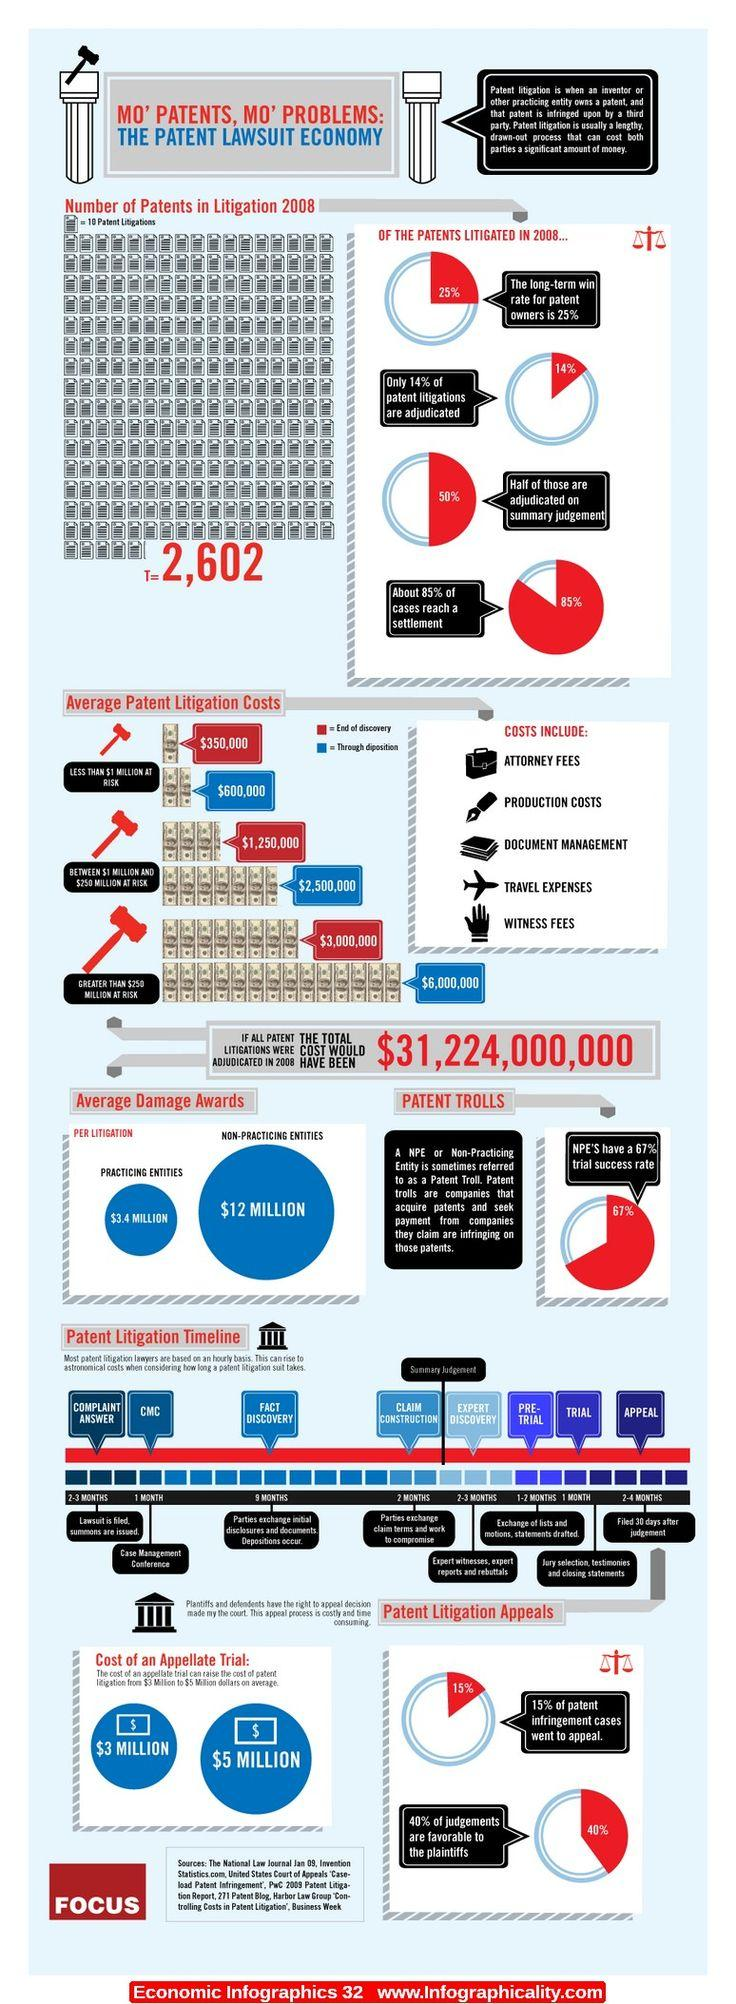Mention a couple of crucial points in this snapshot. Approximately 15% of legal cases do not settle, instead proceeding to trial. The average amount of damage awarded to non-practicing entities in litigation is approximately $12 million. The average damage award for non-practicing entities and practicing entities in litigation is 8.6 million. In 2008, there were 2,602 patents that were involved in litigation. The average amount of damages awarded to practicing entities in litigation is $3.4 million. 